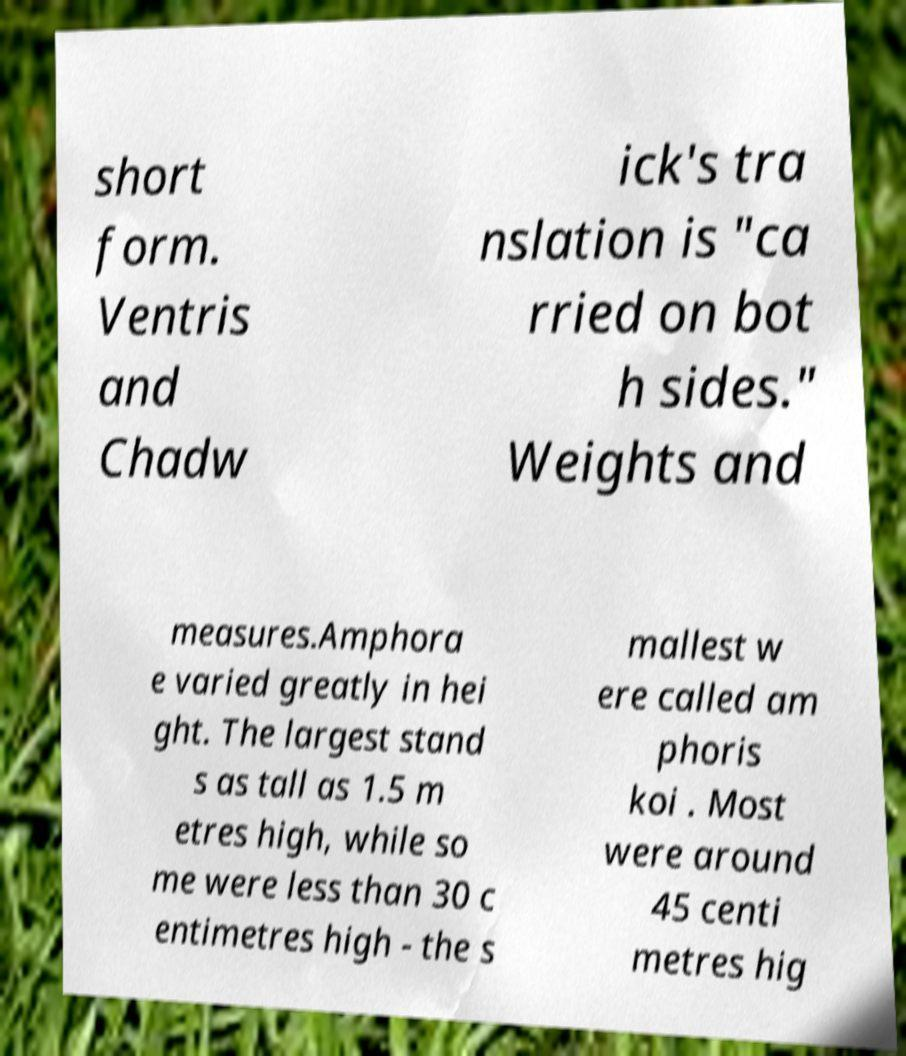I need the written content from this picture converted into text. Can you do that? short form. Ventris and Chadw ick's tra nslation is "ca rried on bot h sides." Weights and measures.Amphora e varied greatly in hei ght. The largest stand s as tall as 1.5 m etres high, while so me were less than 30 c entimetres high - the s mallest w ere called am phoris koi . Most were around 45 centi metres hig 